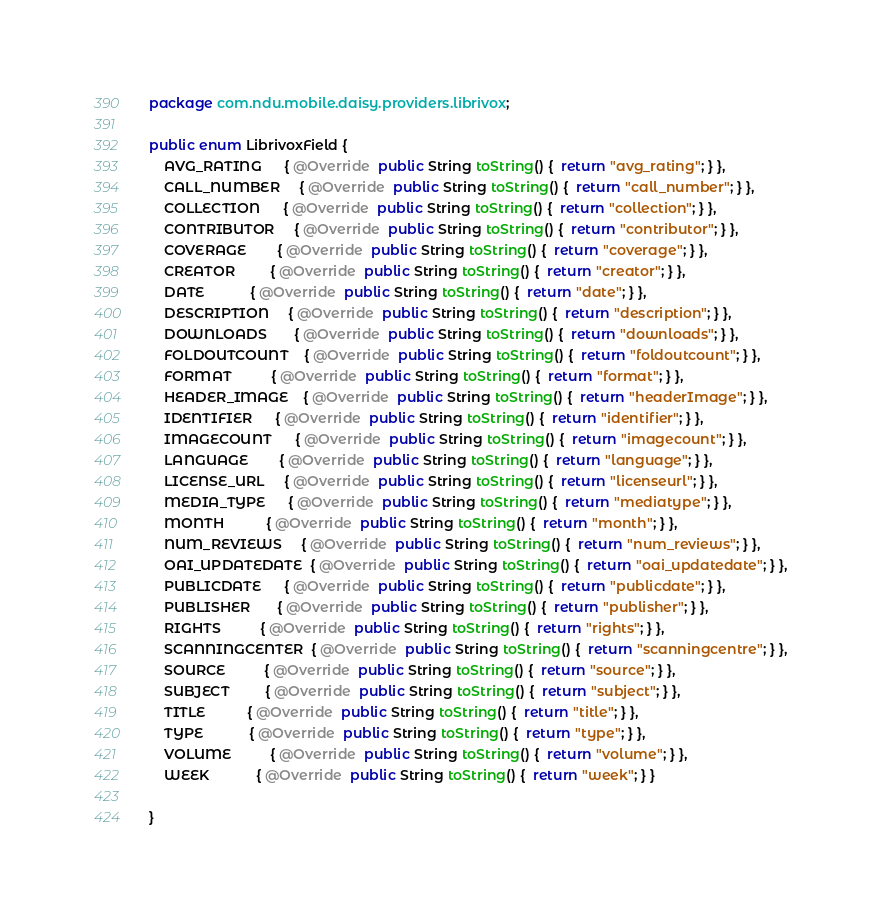Convert code to text. <code><loc_0><loc_0><loc_500><loc_500><_Java_>package com.ndu.mobile.daisy.providers.librivox;

public enum LibrivoxField {
    AVG_RATING      { @Override  public String toString() {  return "avg_rating"; } },
    CALL_NUMBER     { @Override  public String toString() {  return "call_number"; } },
    COLLECTION      { @Override  public String toString() {  return "collection"; } },
    CONTRIBUTOR     { @Override  public String toString() {  return "contributor"; } },
    COVERAGE        { @Override  public String toString() {  return "coverage"; } },
    CREATOR         { @Override  public String toString() {  return "creator"; } },
    DATE            { @Override  public String toString() {  return "date"; } },
    DESCRIPTION     { @Override  public String toString() {  return "description"; } },
    DOWNLOADS       { @Override  public String toString() {  return "downloads"; } },
    FOLDOUTCOUNT    { @Override  public String toString() {  return "foldoutcount"; } },
    FORMAT          { @Override  public String toString() {  return "format"; } },
    HEADER_IMAGE    { @Override  public String toString() {  return "headerImage"; } },
    IDENTIFIER      { @Override  public String toString() {  return "identifier"; } },
    IMAGECOUNT      { @Override  public String toString() {  return "imagecount"; } },
    LANGUAGE        { @Override  public String toString() {  return "language"; } },
    LICENSE_URL     { @Override  public String toString() {  return "licenseurl"; } },
    MEDIA_TYPE      { @Override  public String toString() {  return "mediatype"; } },
    MONTH           { @Override  public String toString() {  return "month"; } },
    NUM_REVIEWS     { @Override  public String toString() {  return "num_reviews"; } },
    OAI_UPDATEDATE  { @Override  public String toString() {  return "oai_updatedate"; } },
    PUBLICDATE      { @Override  public String toString() {  return "publicdate"; } },
    PUBLISHER       { @Override  public String toString() {  return "publisher"; } },
    RIGHTS          { @Override  public String toString() {  return "rights"; } },
    SCANNINGCENTER  { @Override  public String toString() {  return "scanningcentre"; } },
    SOURCE          { @Override  public String toString() {  return "source"; } },
    SUBJECT         { @Override  public String toString() {  return "subject"; } },
    TITLE           { @Override  public String toString() {  return "title"; } },
    TYPE            { @Override  public String toString() {  return "type"; } },
    VOLUME          { @Override  public String toString() {  return "volume"; } },
    WEEK            { @Override  public String toString() {  return "week"; } }

}
</code> 